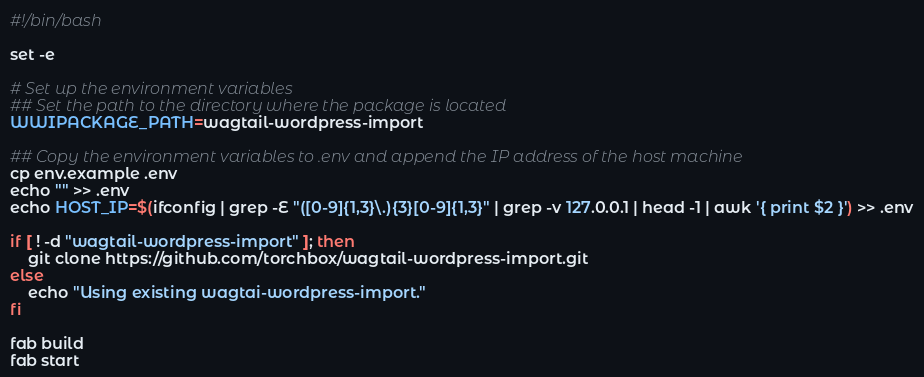<code> <loc_0><loc_0><loc_500><loc_500><_Bash_>#!/bin/bash

set -e

# Set up the environment variables
## Set the path to the directory where the package is located
WWIPACKAGE_PATH=wagtail-wordpress-import

## Copy the environment variables to .env and append the IP address of the host machine
cp env.example .env
echo "" >> .env
echo HOST_IP=$(ifconfig | grep -E "([0-9]{1,3}\.){3}[0-9]{1,3}" | grep -v 127.0.0.1 | head -1 | awk '{ print $2 }') >> .env

if [ ! -d "wagtail-wordpress-import" ]; then
    git clone https://github.com/torchbox/wagtail-wordpress-import.git
else
    echo "Using existing wagtai-wordpress-import."
fi

fab build
fab start</code> 